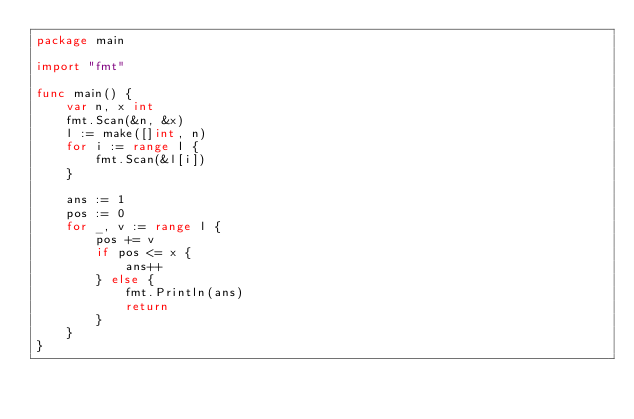<code> <loc_0><loc_0><loc_500><loc_500><_Go_>package main

import "fmt"

func main() {
	var n, x int
	fmt.Scan(&n, &x)
	l := make([]int, n)
	for i := range l {
		fmt.Scan(&l[i])
	}

	ans := 1
	pos := 0
	for _, v := range l {
		pos += v
		if pos <= x {
			ans++
		} else {
			fmt.Println(ans)
			return
		}
	}
}
</code> 